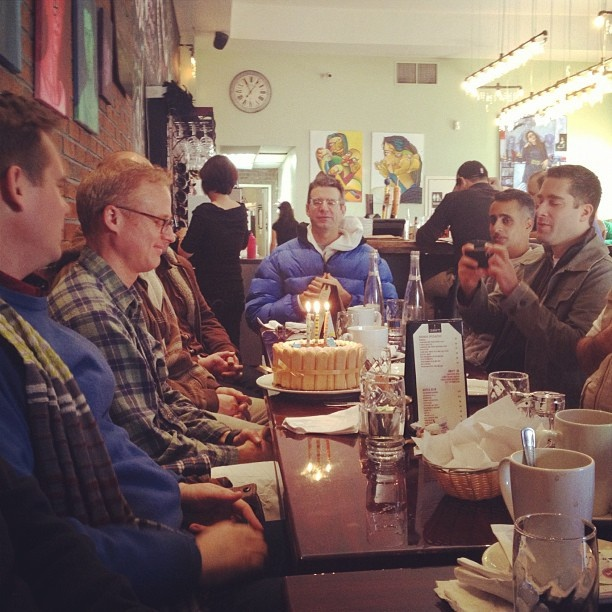Describe the objects in this image and their specific colors. I can see dining table in black, brown, maroon, and tan tones, people in black, brown, navy, and maroon tones, people in black, brown, and maroon tones, people in black, maroon, and brown tones, and people in black, purple, and brown tones in this image. 